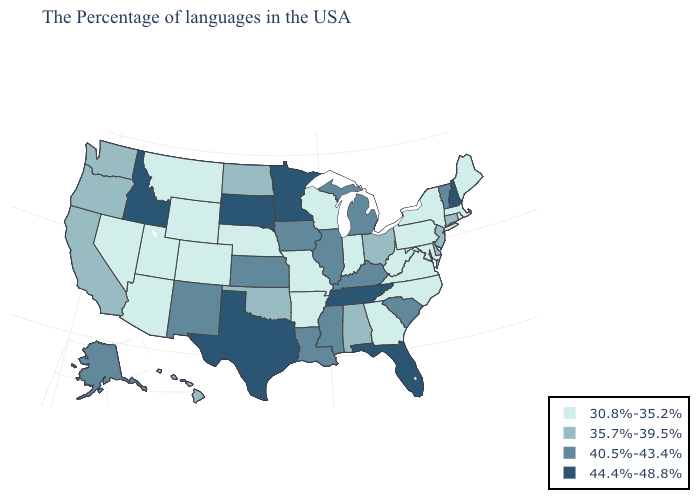Name the states that have a value in the range 44.4%-48.8%?
Quick response, please. New Hampshire, Florida, Tennessee, Minnesota, Texas, South Dakota, Idaho. Name the states that have a value in the range 40.5%-43.4%?
Answer briefly. Vermont, South Carolina, Michigan, Kentucky, Illinois, Mississippi, Louisiana, Iowa, Kansas, New Mexico, Alaska. Among the states that border Oklahoma , does Kansas have the lowest value?
Concise answer only. No. Among the states that border Delaware , does New Jersey have the lowest value?
Answer briefly. No. Which states have the lowest value in the USA?
Short answer required. Maine, Massachusetts, Rhode Island, New York, Maryland, Pennsylvania, Virginia, North Carolina, West Virginia, Georgia, Indiana, Wisconsin, Missouri, Arkansas, Nebraska, Wyoming, Colorado, Utah, Montana, Arizona, Nevada. What is the value of Indiana?
Answer briefly. 30.8%-35.2%. How many symbols are there in the legend?
Answer briefly. 4. Name the states that have a value in the range 44.4%-48.8%?
Write a very short answer. New Hampshire, Florida, Tennessee, Minnesota, Texas, South Dakota, Idaho. Does the map have missing data?
Quick response, please. No. What is the value of Hawaii?
Answer briefly. 35.7%-39.5%. What is the value of Iowa?
Short answer required. 40.5%-43.4%. How many symbols are there in the legend?
Give a very brief answer. 4. Name the states that have a value in the range 35.7%-39.5%?
Answer briefly. Connecticut, New Jersey, Delaware, Ohio, Alabama, Oklahoma, North Dakota, California, Washington, Oregon, Hawaii. Among the states that border Missouri , which have the lowest value?
Write a very short answer. Arkansas, Nebraska. 